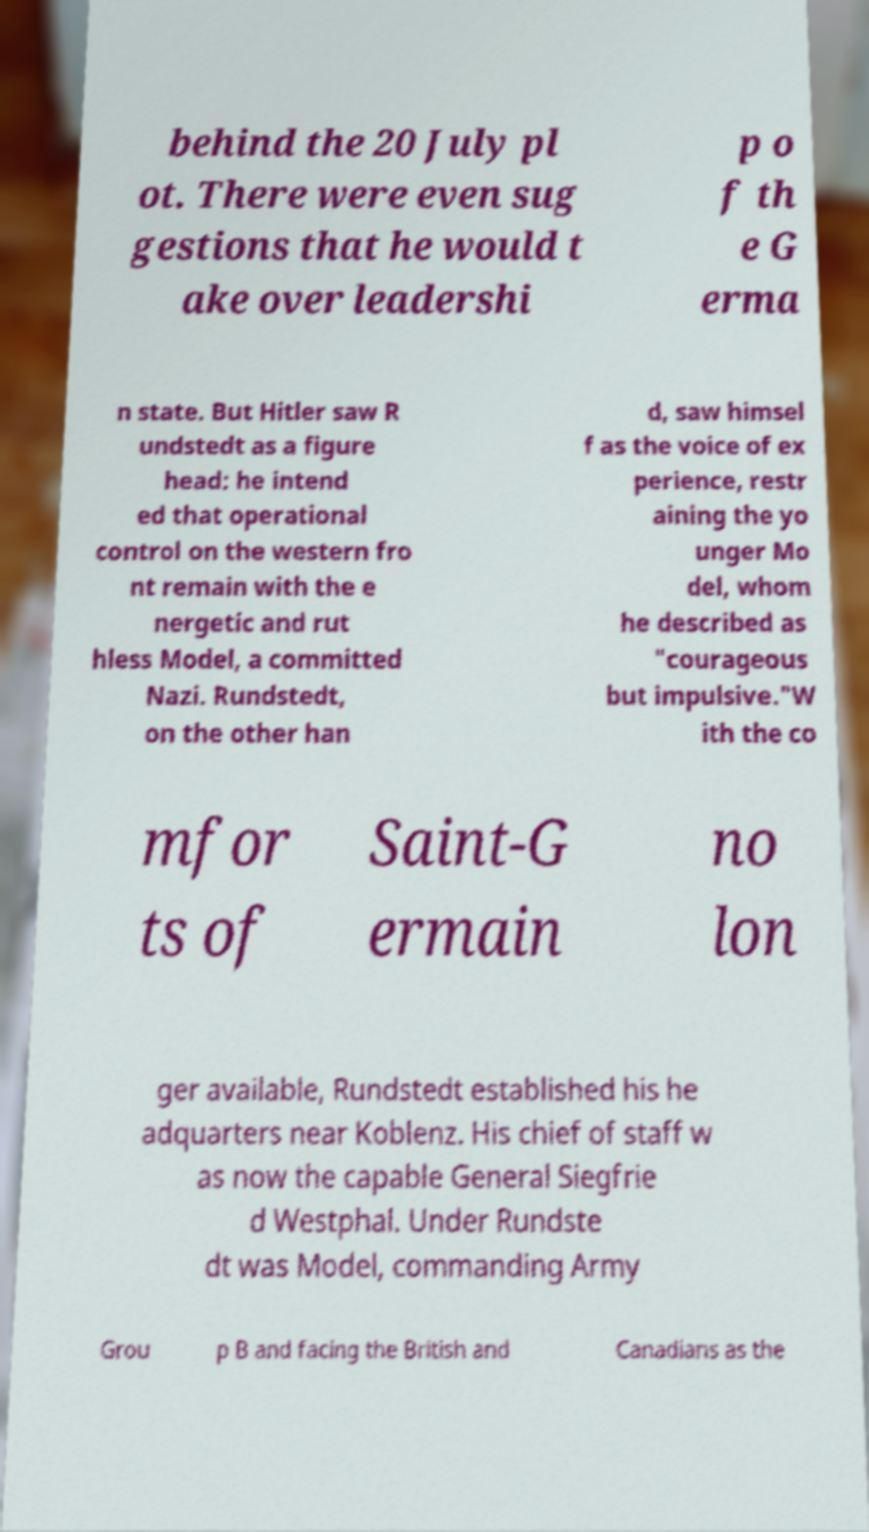Could you extract and type out the text from this image? behind the 20 July pl ot. There were even sug gestions that he would t ake over leadershi p o f th e G erma n state. But Hitler saw R undstedt as a figure head: he intend ed that operational control on the western fro nt remain with the e nergetic and rut hless Model, a committed Nazi. Rundstedt, on the other han d, saw himsel f as the voice of ex perience, restr aining the yo unger Mo del, whom he described as "courageous but impulsive."W ith the co mfor ts of Saint-G ermain no lon ger available, Rundstedt established his he adquarters near Koblenz. His chief of staff w as now the capable General Siegfrie d Westphal. Under Rundste dt was Model, commanding Army Grou p B and facing the British and Canadians as the 